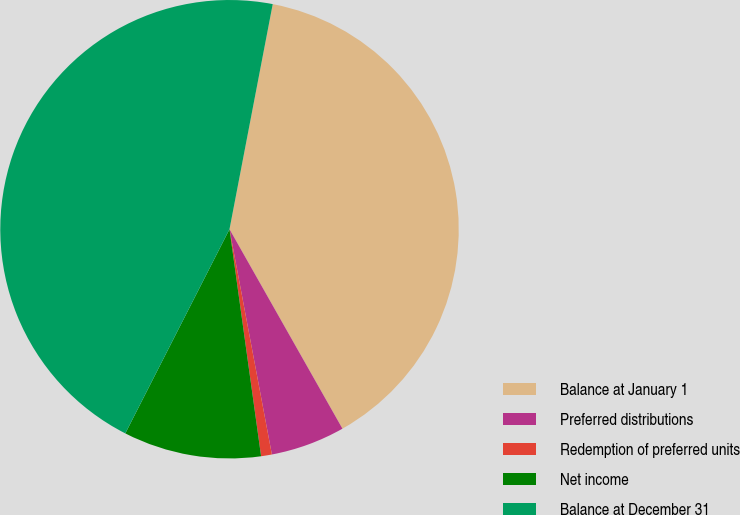Convert chart to OTSL. <chart><loc_0><loc_0><loc_500><loc_500><pie_chart><fcel>Balance at January 1<fcel>Preferred distributions<fcel>Redemption of preferred units<fcel>Net income<fcel>Balance at December 31<nl><fcel>38.78%<fcel>5.24%<fcel>0.76%<fcel>9.71%<fcel>45.51%<nl></chart> 